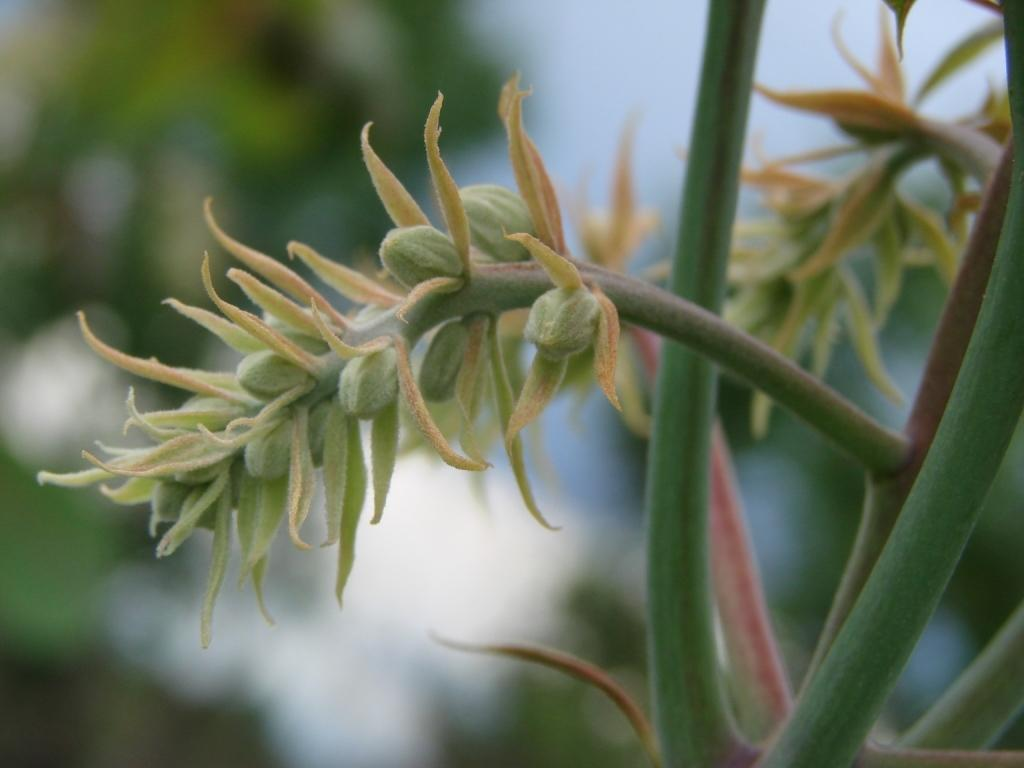What type of living organisms can be seen in the image? Plants can be seen in the image. What part of the plants is visible in the background of the image? Leaves are visible in the background of the image. How would you describe the clarity of the image? The image is blurry. What religious symbol can be seen in the image? There is no religious symbol present in the image; it features plants and leaves. What type of gold object is visible in the image? There is no gold object present in the image. 